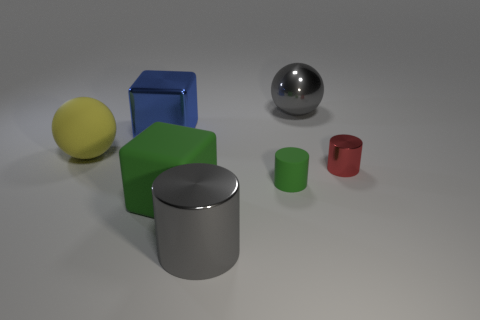Is the number of small metallic things greater than the number of blue matte things?
Give a very brief answer. Yes. Is the color of the small cylinder that is to the left of the big shiny sphere the same as the large rubber cube?
Provide a succinct answer. Yes. What color is the large shiny ball?
Your response must be concise. Gray. Are there any shiny objects behind the big shiny object that is to the right of the big shiny cylinder?
Give a very brief answer. No. There is a gray metallic object in front of the large matte object that is right of the yellow matte sphere; what is its shape?
Your answer should be compact. Cylinder. Are there fewer big green objects than large green metallic blocks?
Ensure brevity in your answer.  No. Are the red thing and the blue thing made of the same material?
Ensure brevity in your answer.  Yes. What color is the shiny object that is behind the red shiny thing and left of the gray shiny ball?
Give a very brief answer. Blue. Is there a blue rubber object of the same size as the blue metal thing?
Your answer should be very brief. No. There is a metal cylinder that is right of the large gray object in front of the large green rubber cube; what size is it?
Your answer should be very brief. Small. 